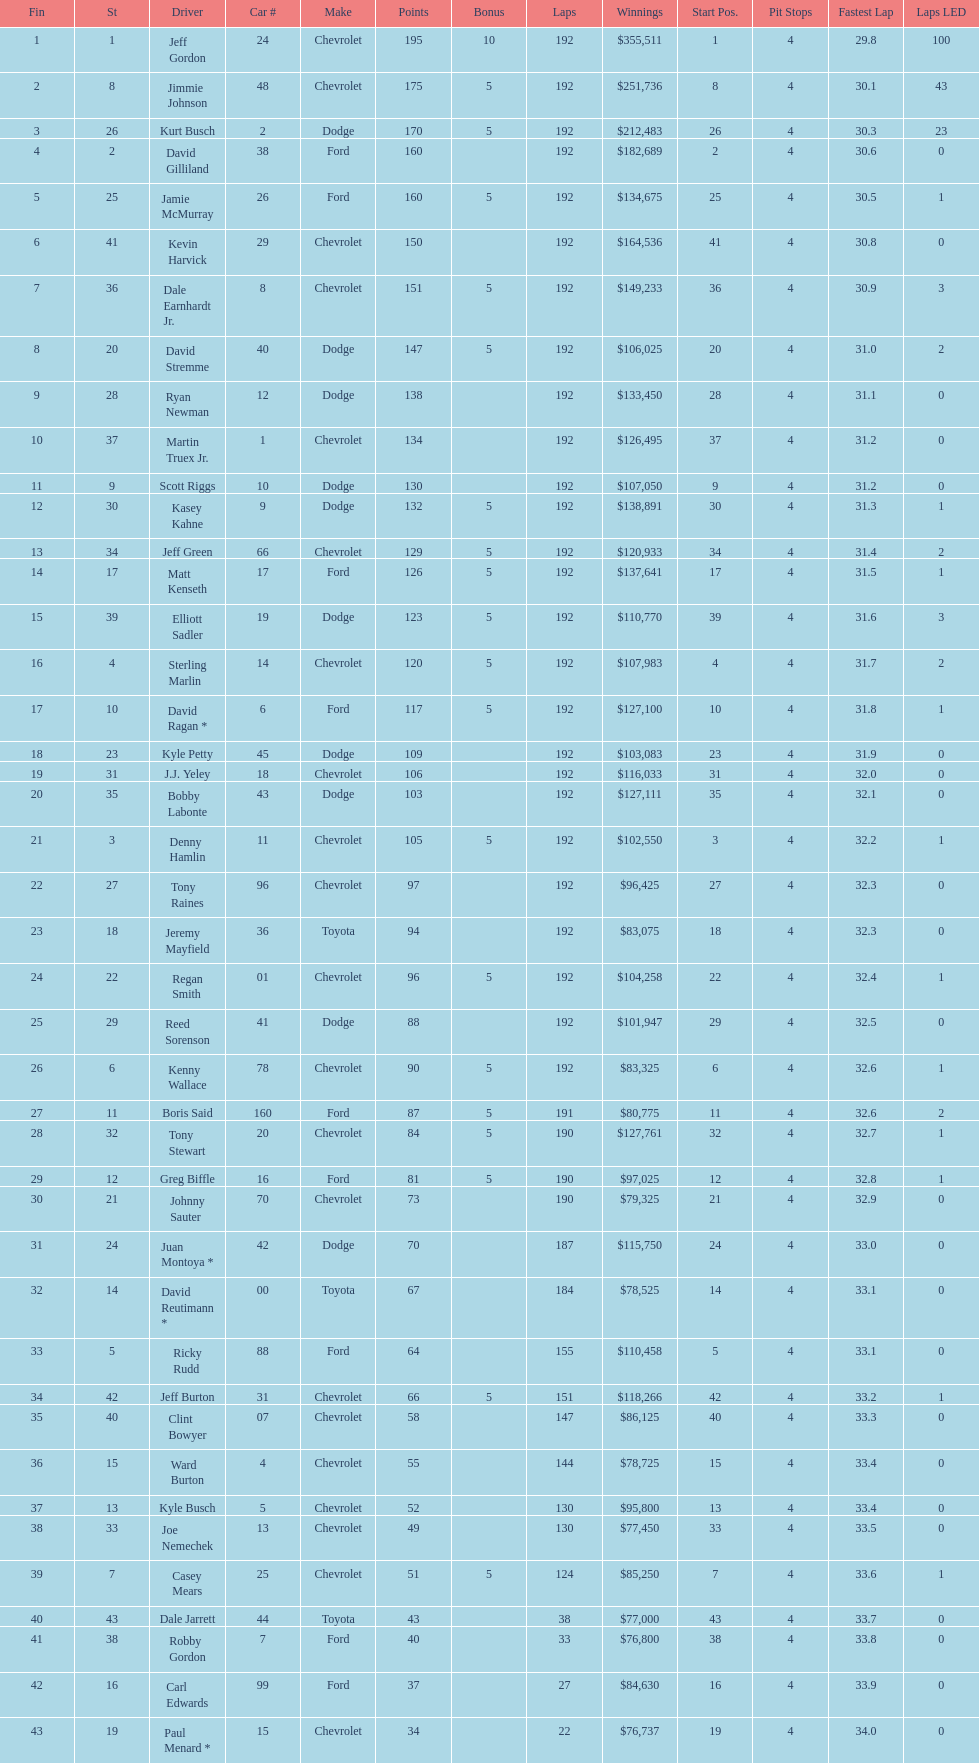What driver earned the least amount of winnings? Paul Menard *. 